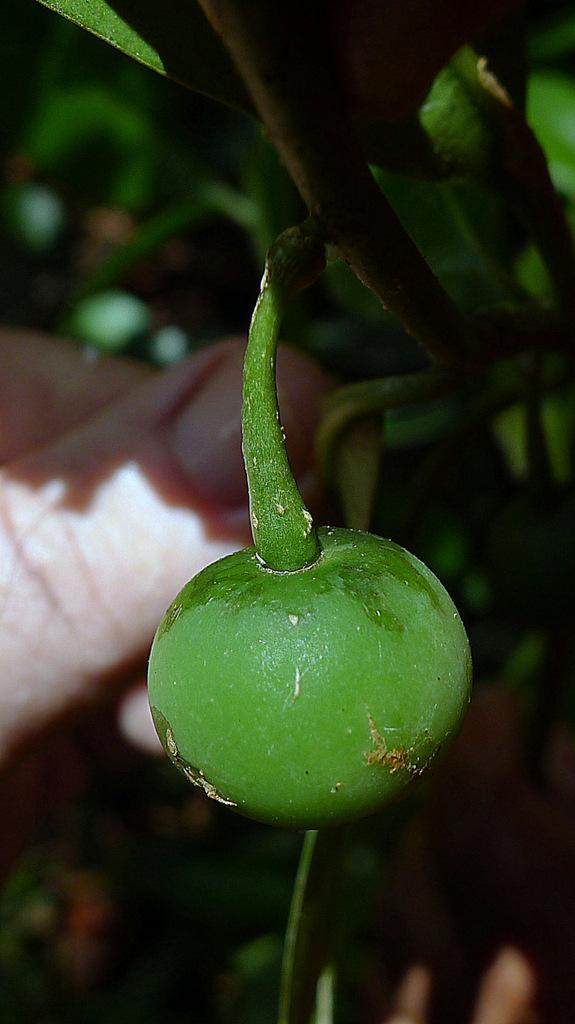What type of fruit can be seen in the image? There is a fruit on a plant in the image, and it is green in color. Can you describe the color of the fruit? The fruit is green in color. What is visible on the left side of the image? There are fingers visible on the left side of the image. How would you describe the background of the image? The background of the image is blurred. How many goldfish are swimming in the fruit in the image? There are no goldfish present in the image; it features a green fruit on a plant. What type of corn is growing next to the fruit in the image? There is no corn present in the image; it only features a green fruit on a plant. 